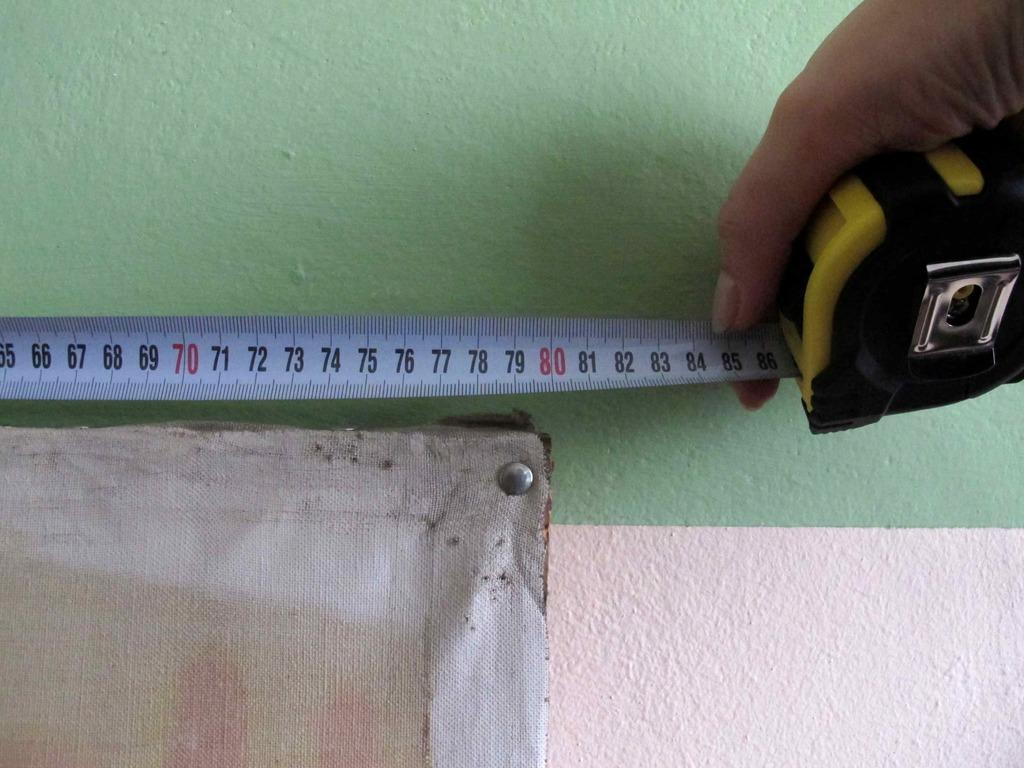What part of a person is visible in the image? A person's hand is visible in the image. What is the person holding in their hand? The person is holding a tape in their hand. What can be seen on the left side of the image? There is a board on the left side of the image. What is visible in the background of the image? There is a wall in the background of the image. What type of marble is present on the board in the image? There is no marble present on the board in the image; it is a tape that the person is holding. 